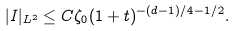Convert formula to latex. <formula><loc_0><loc_0><loc_500><loc_500>| I | _ { L ^ { 2 } } \leq C \zeta _ { 0 } ( 1 + t ) ^ { - ( d - 1 ) / 4 - 1 / 2 } .</formula> 